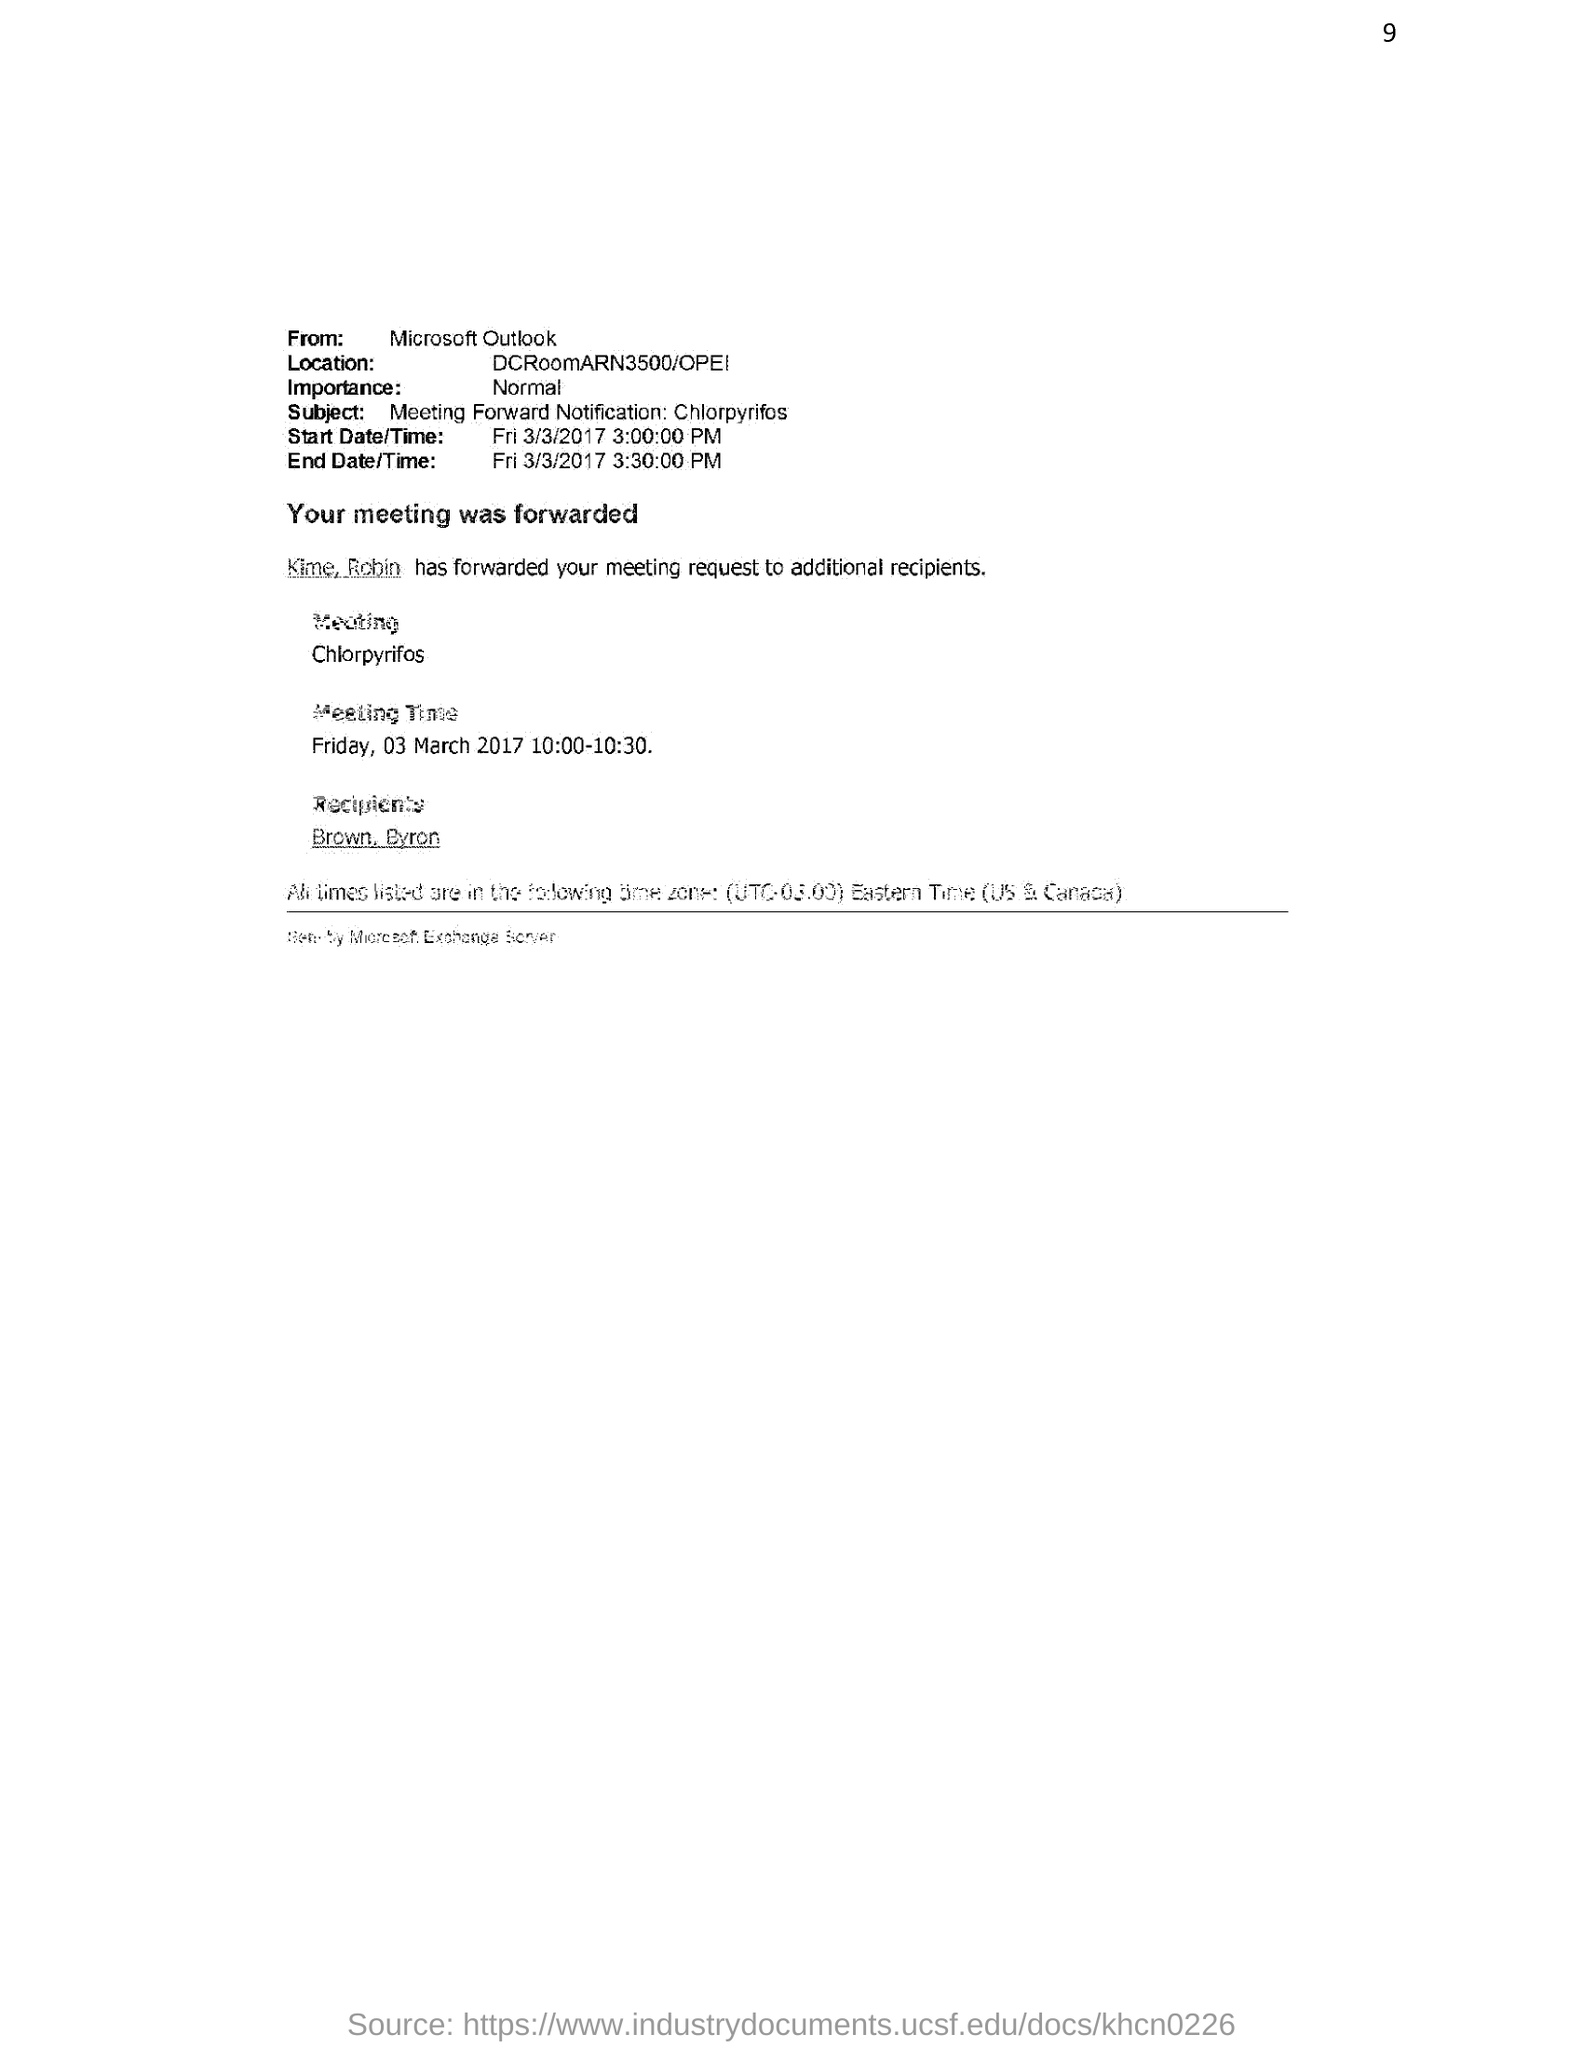Highlight a few significant elements in this photo. The sender of the email is Microsoft Outlook. The recipient of the meeting request is Brown and Byron. The start date/time mentioned in the email is Friday, March 3, 2017 at 3:00:00 PM. The subject of this email is the notification of a meeting regarding the topic of "Chlorpyrifos. This email is of significant importance and should be treated as normal. 